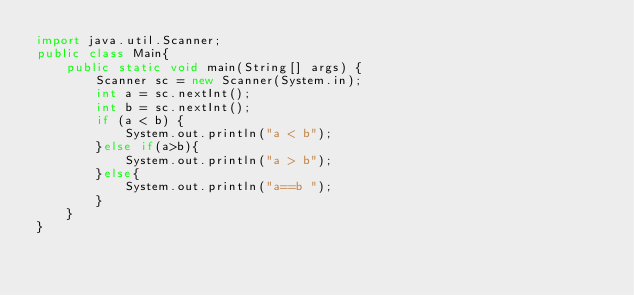<code> <loc_0><loc_0><loc_500><loc_500><_Java_>import java.util.Scanner;
public class Main{
	public static void main(String[] args) {
		Scanner sc = new Scanner(System.in);
		int a = sc.nextInt();
		int b = sc.nextInt();
		if (a < b) {
			System.out.println("a < b");
		}else if(a>b){
			System.out.println("a > b"); 
		}else{
			System.out.println("a==b ");
		}
	}
}</code> 